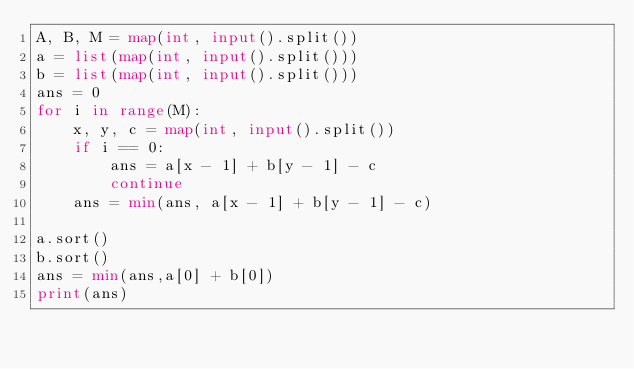Convert code to text. <code><loc_0><loc_0><loc_500><loc_500><_Python_>A, B, M = map(int, input().split())
a = list(map(int, input().split()))
b = list(map(int, input().split()))
ans = 0
for i in range(M):
    x, y, c = map(int, input().split())
    if i == 0:
        ans = a[x - 1] + b[y - 1] - c
        continue
    ans = min(ans, a[x - 1] + b[y - 1] - c)

a.sort()
b.sort()
ans = min(ans,a[0] + b[0])
print(ans)</code> 